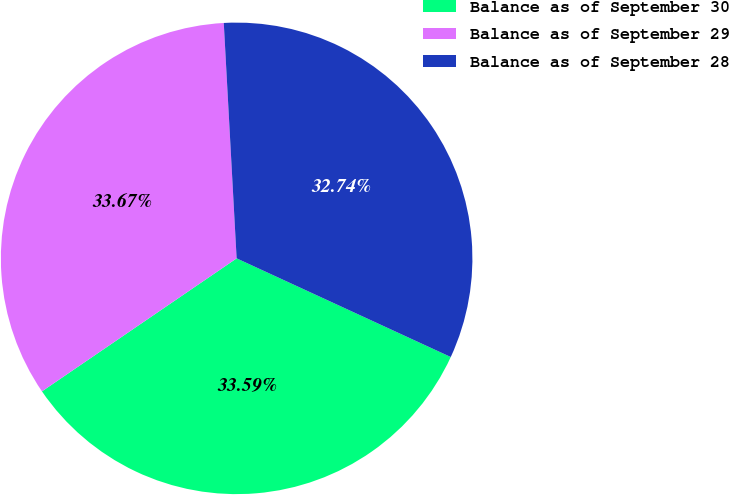<chart> <loc_0><loc_0><loc_500><loc_500><pie_chart><fcel>Balance as of September 30<fcel>Balance as of September 29<fcel>Balance as of September 28<nl><fcel>33.59%<fcel>33.67%<fcel>32.74%<nl></chart> 